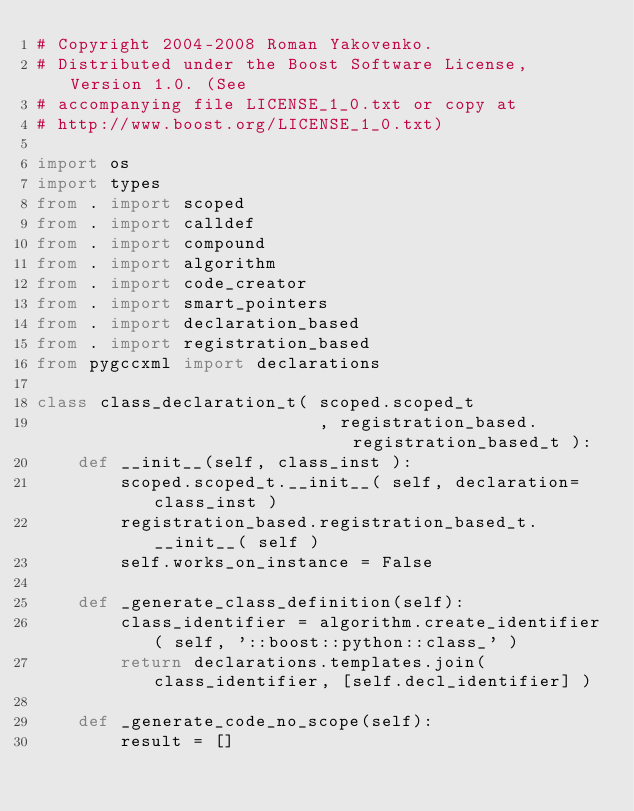Convert code to text. <code><loc_0><loc_0><loc_500><loc_500><_Python_># Copyright 2004-2008 Roman Yakovenko.
# Distributed under the Boost Software License, Version 1.0. (See
# accompanying file LICENSE_1_0.txt or copy at
# http://www.boost.org/LICENSE_1_0.txt)

import os
import types
from . import scoped
from . import calldef
from . import compound
from . import algorithm
from . import code_creator
from . import smart_pointers
from . import declaration_based
from . import registration_based
from pygccxml import declarations

class class_declaration_t( scoped.scoped_t
                           , registration_based.registration_based_t ):
    def __init__(self, class_inst ):
        scoped.scoped_t.__init__( self, declaration=class_inst )
        registration_based.registration_based_t.__init__( self )
        self.works_on_instance = False

    def _generate_class_definition(self):
        class_identifier = algorithm.create_identifier( self, '::boost::python::class_' )
        return declarations.templates.join( class_identifier, [self.decl_identifier] )

    def _generate_code_no_scope(self):
        result = []</code> 